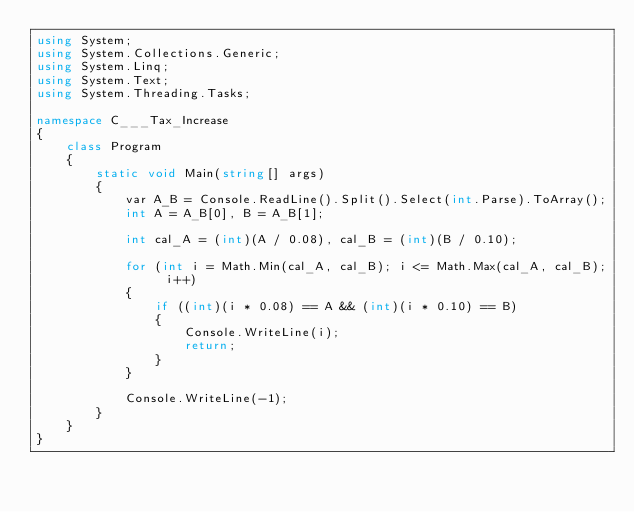<code> <loc_0><loc_0><loc_500><loc_500><_C#_>using System;
using System.Collections.Generic;
using System.Linq;
using System.Text;
using System.Threading.Tasks;

namespace C___Tax_Increase
{
    class Program
    {
        static void Main(string[] args)
        {
            var A_B = Console.ReadLine().Split().Select(int.Parse).ToArray();
            int A = A_B[0], B = A_B[1];

            int cal_A = (int)(A / 0.08), cal_B = (int)(B / 0.10);

            for (int i = Math.Min(cal_A, cal_B); i <= Math.Max(cal_A, cal_B); i++)
            {
                if ((int)(i * 0.08) == A && (int)(i * 0.10) == B)
                {
                    Console.WriteLine(i);
                    return;
                }
            }

            Console.WriteLine(-1);
        }
    }
}
</code> 